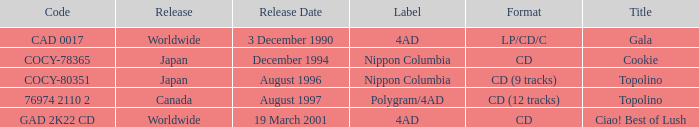What format was released in August 1996? CD (9 tracks). 